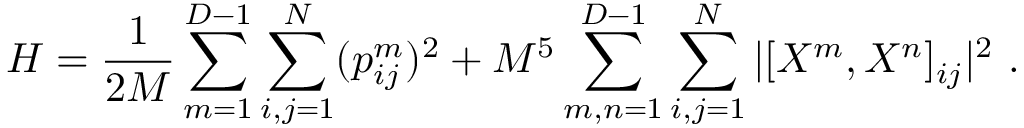<formula> <loc_0><loc_0><loc_500><loc_500>H = \frac { 1 } { 2 M } \sum _ { m = 1 } ^ { D - 1 } \sum _ { i , j = 1 } ^ { N } ( p _ { i j } ^ { m } ) ^ { 2 } + M ^ { 5 } \sum _ { m , n = 1 } ^ { D - 1 } \sum _ { i , j = 1 } ^ { N } | [ X ^ { m } , X ^ { n } ] _ { i j } | ^ { 2 } \ .</formula> 